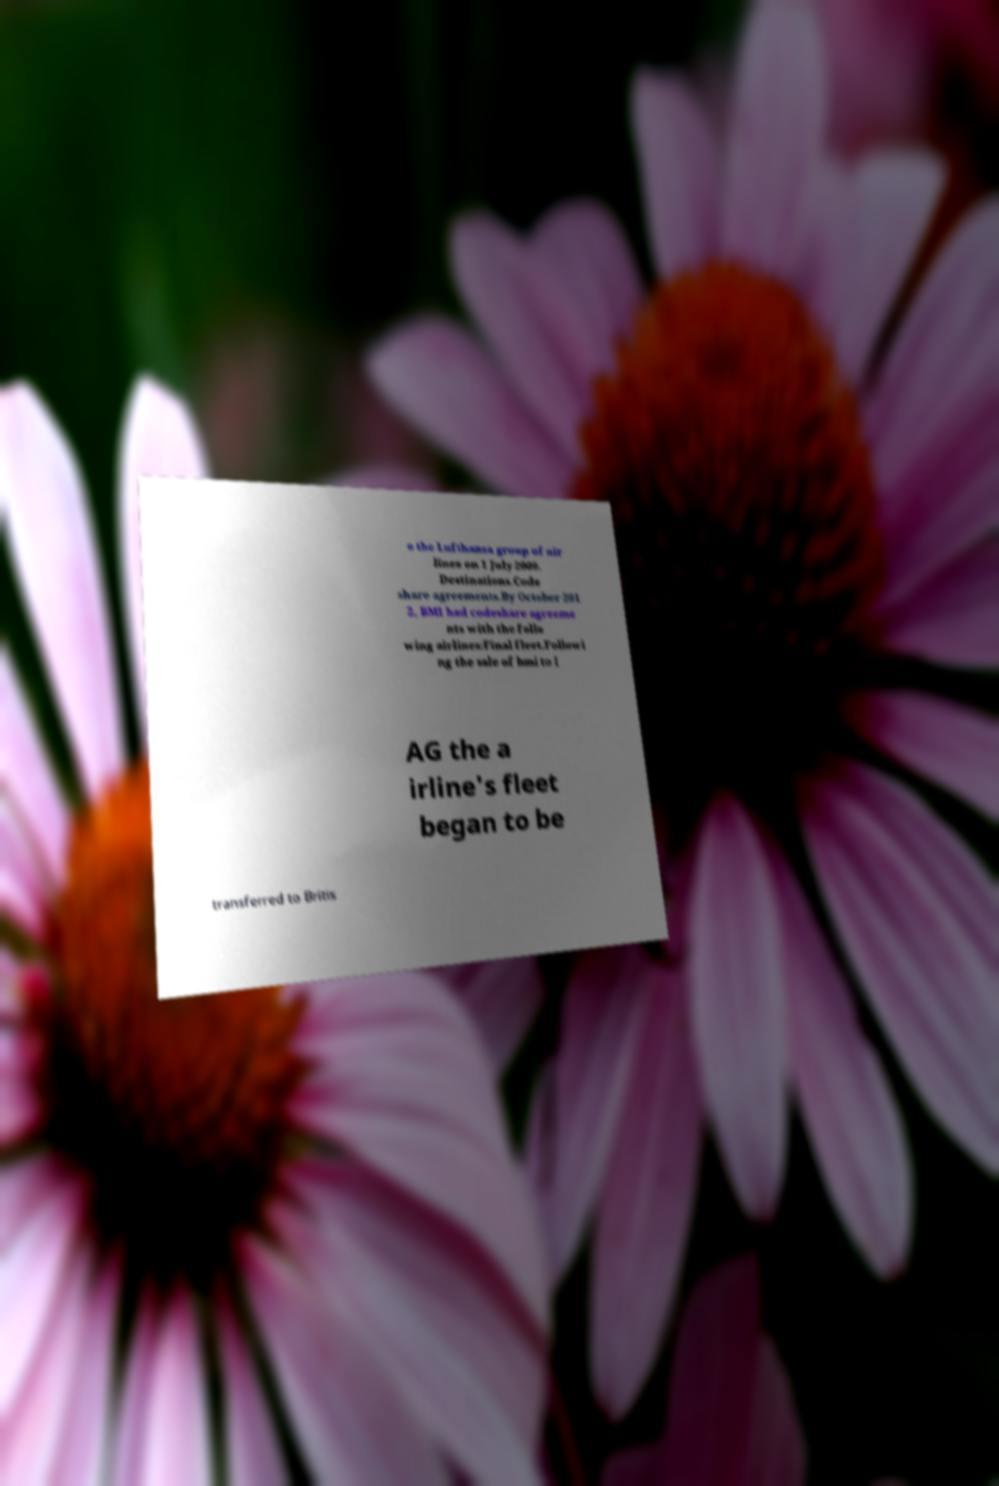Could you extract and type out the text from this image? o the Lufthansa group of air lines on 1 July 2009. Destinations.Code share agreements.By October 201 2, BMI had codeshare agreeme nts with the follo wing airlines:Final fleet.Followi ng the sale of bmi to I AG the a irline's fleet began to be transferred to Britis 